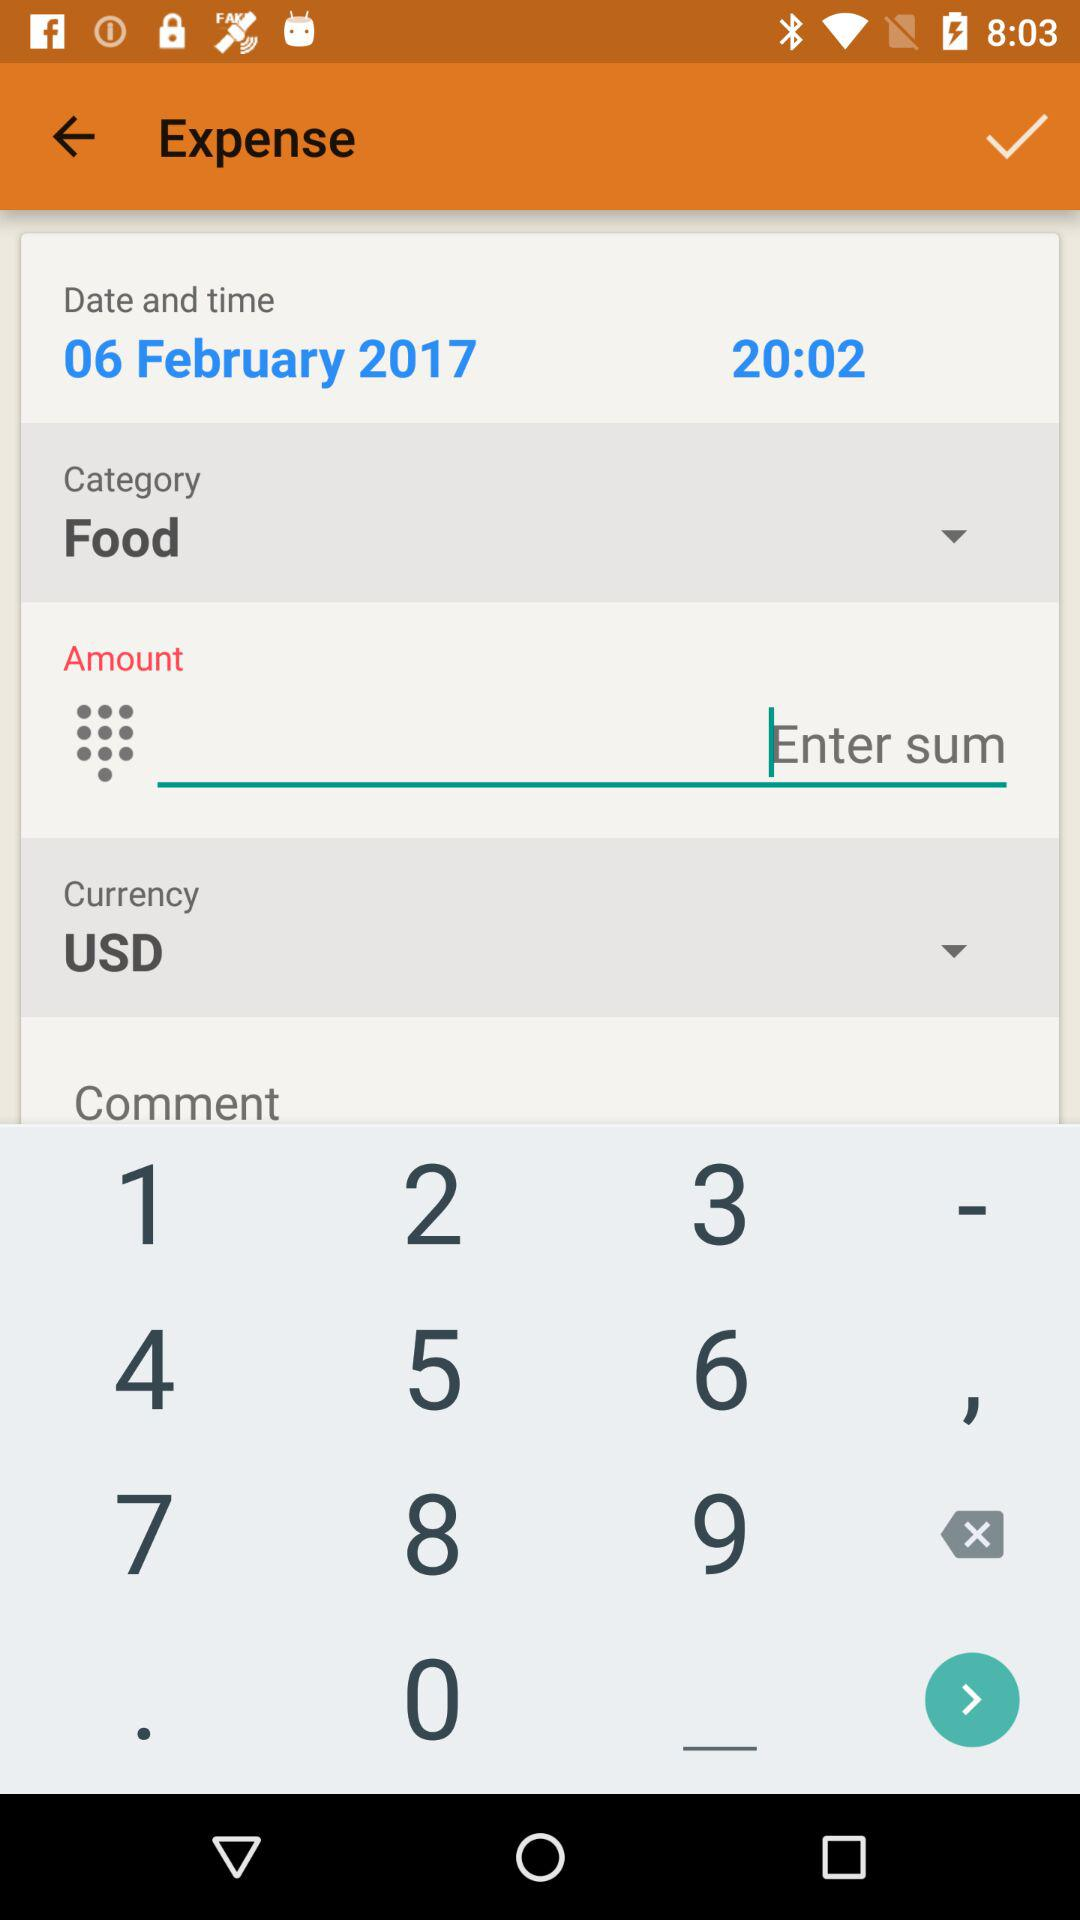What is the selected currency? The selected currency is USD. 